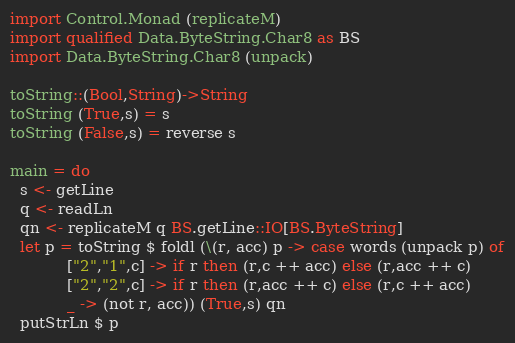<code> <loc_0><loc_0><loc_500><loc_500><_Haskell_>import Control.Monad (replicateM)
import qualified Data.ByteString.Char8 as BS
import Data.ByteString.Char8 (unpack)

toString::(Bool,String)->String
toString (True,s) = s
toString (False,s) = reverse s

main = do
  s <- getLine
  q <- readLn
  qn <- replicateM q BS.getLine::IO[BS.ByteString]
  let p = toString $ foldl (\(r, acc) p -> case words (unpack p) of
            ["2","1",c] -> if r then (r,c ++ acc) else (r,acc ++ c)
            ["2","2",c] -> if r then (r,acc ++ c) else (r,c ++ acc)
            _ -> (not r, acc)) (True,s) qn
  putStrLn $ p</code> 